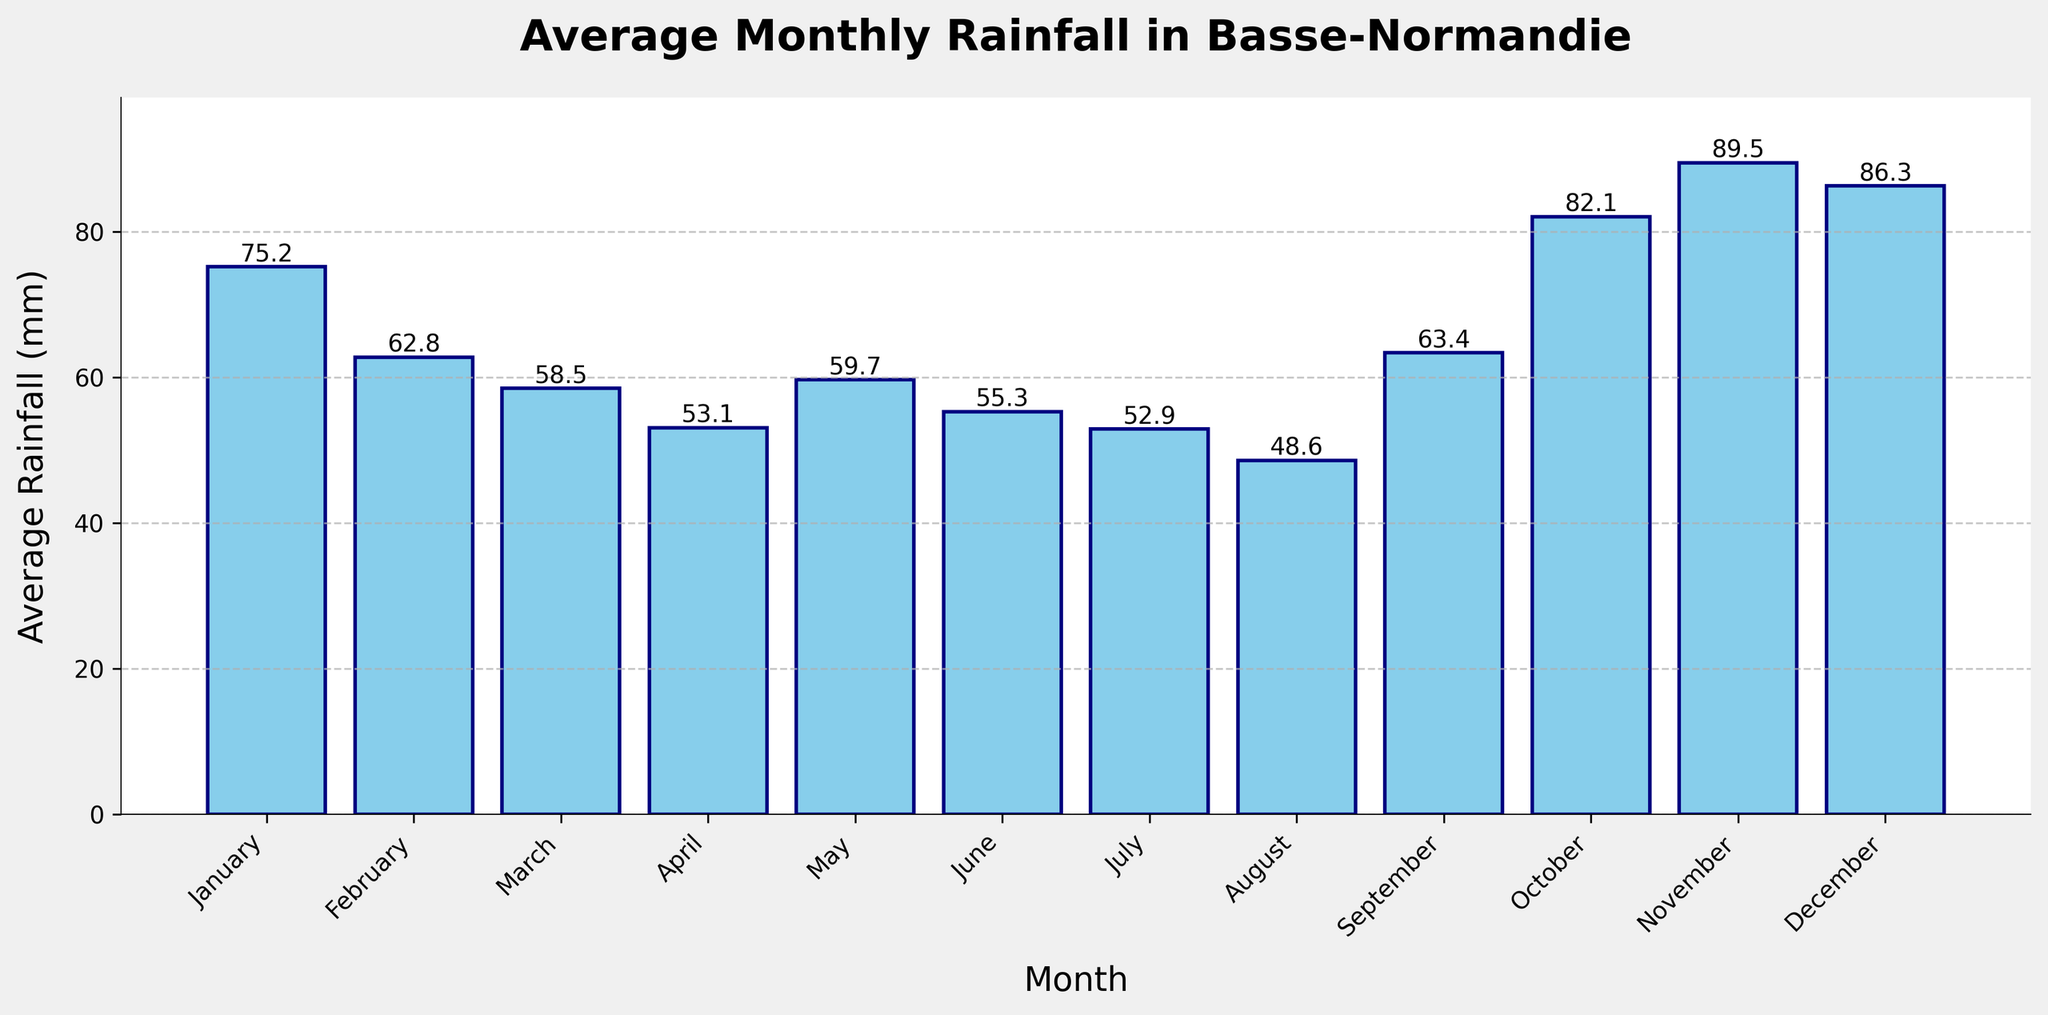What's the month with the highest average rainfall? First, visually inspect the bar heights and labels on top of the bars to find the highest value. The tallest bar corresponds to November, which has the label 89.5 mm.
Answer: November Which month has the lowest average rainfall, and how much is it? Visually scan the bar chart for the shortest bar. The bar for August is the shortest with a labeled value of 48.6 mm.
Answer: August, 48.6 mm What's the difference between the average rainfall in November and April? Identify the rainfall values for both November (89.5 mm) and April (53.1 mm). Calculate the difference: 89.5 mm - 53.1 mm = 36.4 mm.
Answer: 36.4 mm Which months have an average rainfall greater than 80 mm? Look at the bars and their labels. November (89.5 mm), October (82.1 mm), and December (86.3 mm) all have values greater than 80 mm.
Answer: November, October, December How does the average rainfall in January compare to that in July? January has an average rainfall of 75.2 mm while July has 52.9 mm. January's rainfall is greater.
Answer: January has more rainfall What is the combined average rainfall for June, July, and August? Sum the rainfall values for June (55.3 mm), July (52.9 mm), and August (48.6 mm): 55.3 mm + 52.9 mm + 48.6 mm = 156.8 mm.
Answer: 156.8 mm What is the average rainfall for the first half of the year (January to June)? Average the values for January (75.2 mm), February (62.8 mm), March (58.5 mm), April (53.1 mm), May (59.7 mm), and June (55.3 mm). Sum is 364.6 mm. Divide by 6: 364.6 mm / 6 = 60.8 mm.
Answer: 60.8 mm How does the rainfall in May compare to September? May and September have almost similar average rainfall with May at 59.7 mm and September at 63.4 mm. September has slightly more rainfall.
Answer: September has slightly more What is the total average rainfall for the months with below 60 mm? Sum the average rainfalls for March (58.5 mm), April (53.1 mm), June (55.3 mm), July (52.9 mm), and August (48.6 mm): 58.5 + 53.1 + 55.3 + 52.9 + 48.6 = 268.4 mm.
Answer: 268.4 mm 